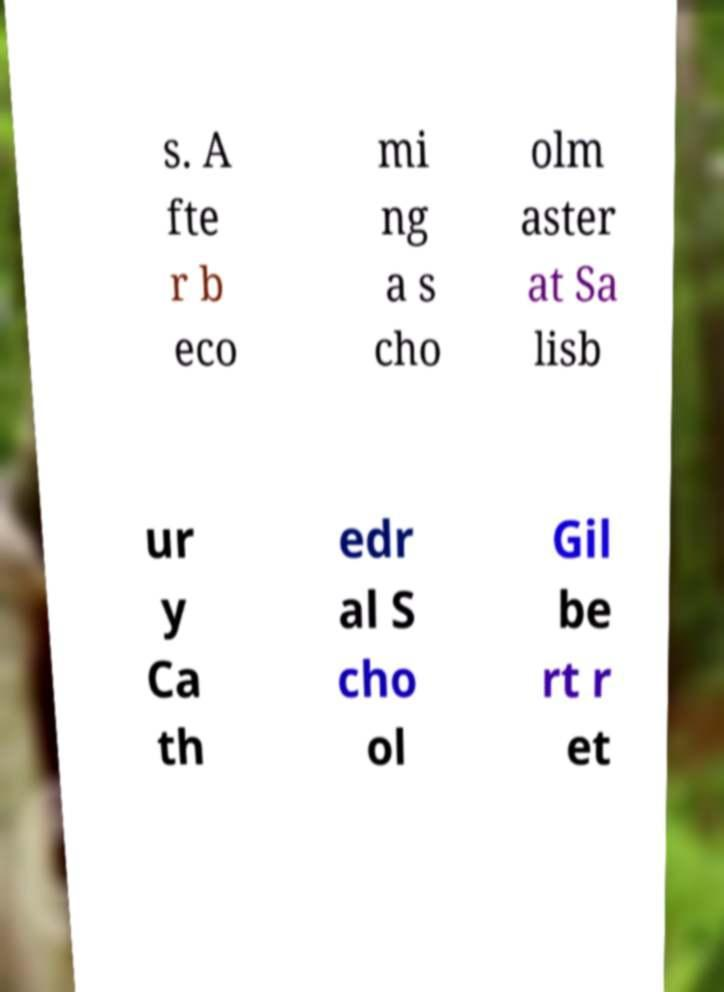I need the written content from this picture converted into text. Can you do that? s. A fte r b eco mi ng a s cho olm aster at Sa lisb ur y Ca th edr al S cho ol Gil be rt r et 